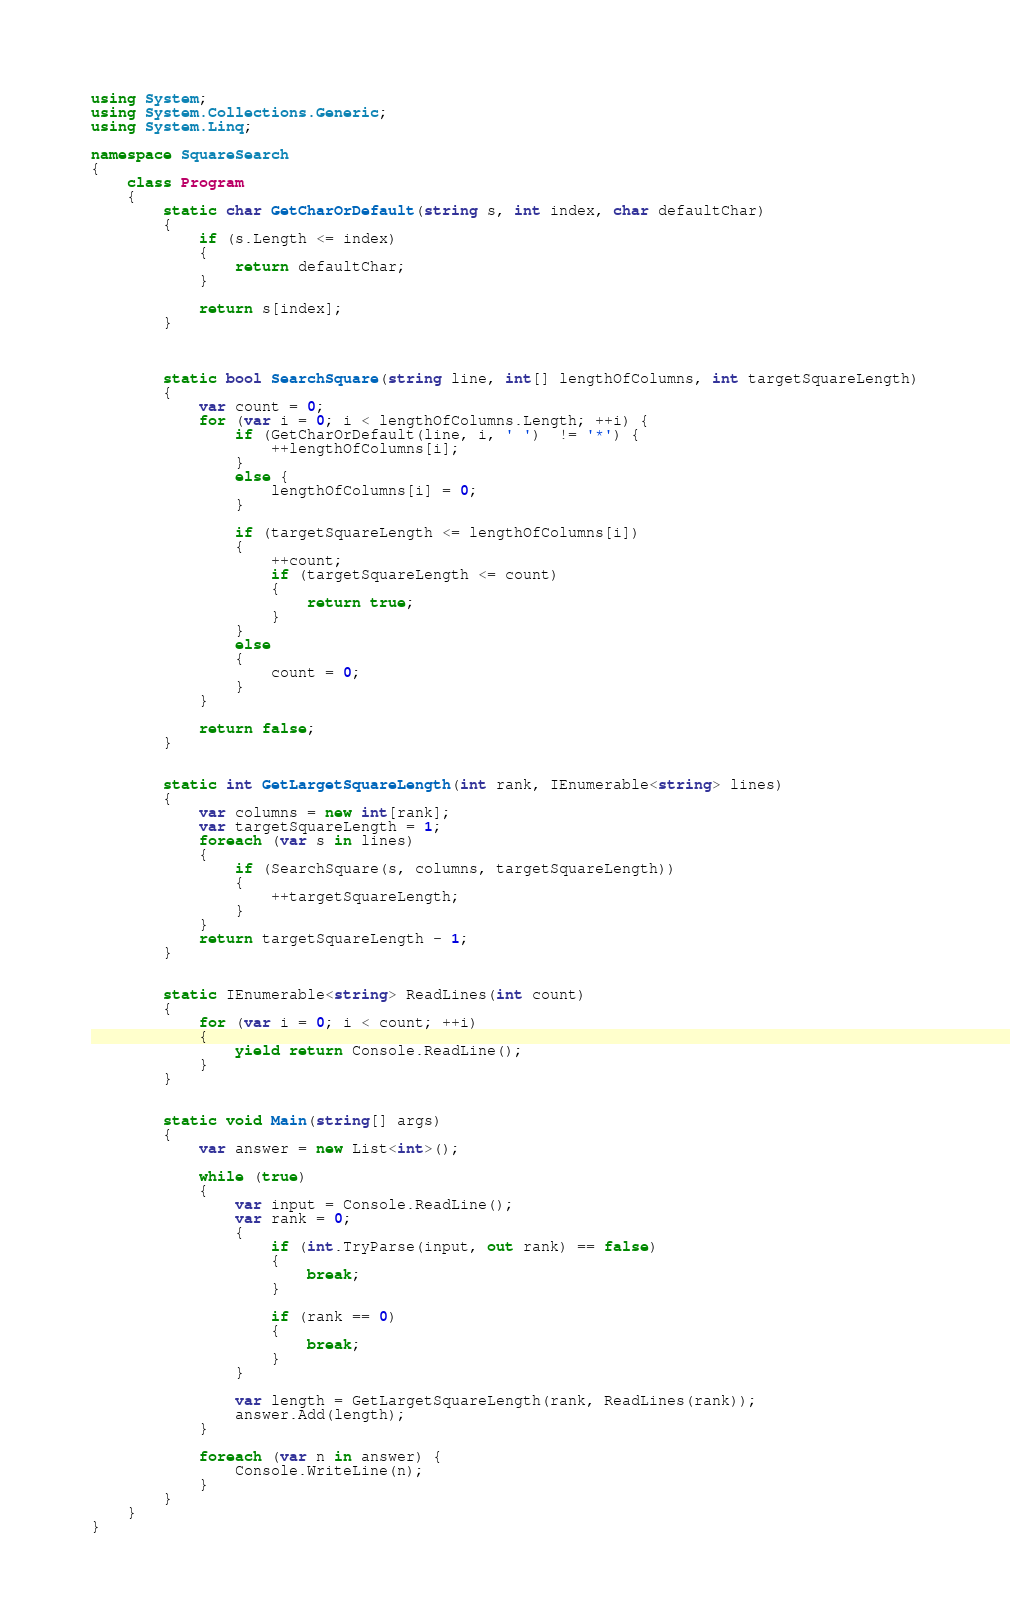Convert code to text. <code><loc_0><loc_0><loc_500><loc_500><_C#_>using System;
using System.Collections.Generic;
using System.Linq;
 
namespace SquareSearch
{
    class Program
    {
        static char GetCharOrDefault(string s, int index, char defaultChar)
        {
            if (s.Length <= index)
            {
                return defaultChar;
            }
 
            return s[index];
        }
 
 
 
        static bool SearchSquare(string line, int[] lengthOfColumns, int targetSquareLength)
        {
            var count = 0;
            for (var i = 0; i < lengthOfColumns.Length; ++i) { 
                if (GetCharOrDefault(line, i, ' ')  != '*') {
                    ++lengthOfColumns[i];
                }
                else {
                    lengthOfColumns[i] = 0;
                }
 
                if (targetSquareLength <= lengthOfColumns[i])
                {
                    ++count;
                    if (targetSquareLength <= count)
                    {
                        return true;
                    }
                }
                else
                {
                    count = 0;
                }
            }
 
            return false;
        }
 
 
        static int GetLargetSquareLength(int rank, IEnumerable<string> lines)
        {
            var columns = new int[rank];
            var targetSquareLength = 1;
            foreach (var s in lines)
            {
                if (SearchSquare(s, columns, targetSquareLength))
                {
                    ++targetSquareLength;
                }
            }
            return targetSquareLength - 1;
        }
 
 
        static IEnumerable<string> ReadLines(int count)
        {
            for (var i = 0; i < count; ++i)
            {
                yield return Console.ReadLine();
            }
        }
 
 
        static void Main(string[] args)
        {
            var answer = new List<int>();
 
            while (true) 
            {
                var input = Console.ReadLine();
                var rank = 0;
                {
                    if (int.TryParse(input, out rank) == false)
                    {
                        break;
                    }
 
                    if (rank == 0)
                    {
                        break;
                    }
                }
 
                var length = GetLargetSquareLength(rank, ReadLines(rank));
                answer.Add(length);
            }
 
            foreach (var n in answer) {
                Console.WriteLine(n);
            }
        }
    }
}</code> 